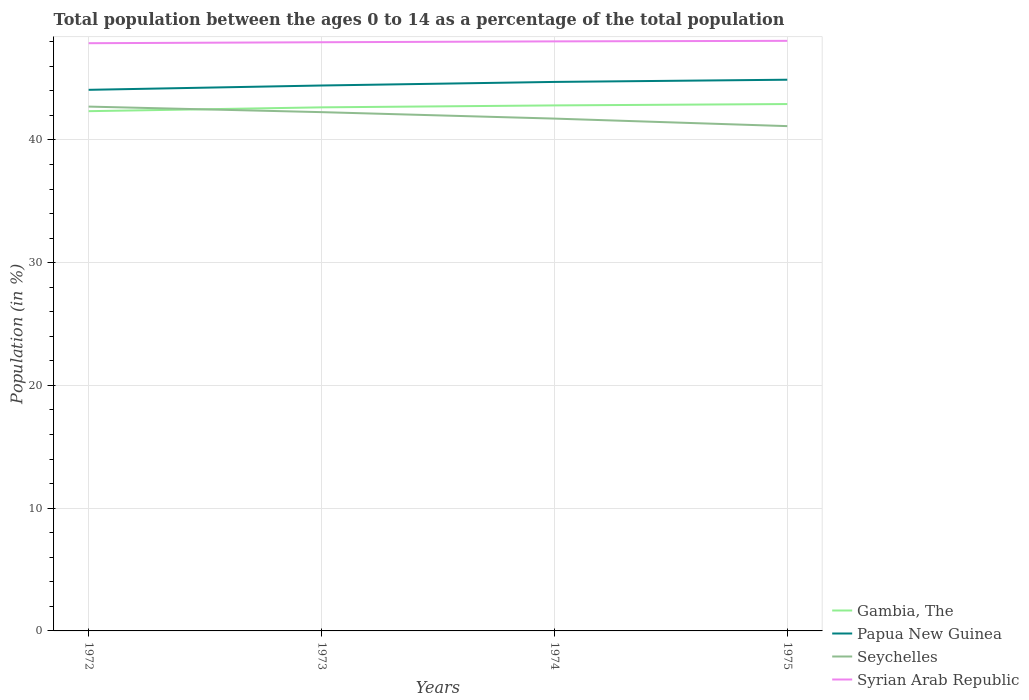Is the number of lines equal to the number of legend labels?
Your answer should be very brief. Yes. Across all years, what is the maximum percentage of the population ages 0 to 14 in Syrian Arab Republic?
Offer a terse response. 47.88. In which year was the percentage of the population ages 0 to 14 in Seychelles maximum?
Provide a succinct answer. 1975. What is the total percentage of the population ages 0 to 14 in Syrian Arab Republic in the graph?
Offer a very short reply. -0.08. What is the difference between the highest and the second highest percentage of the population ages 0 to 14 in Gambia, The?
Make the answer very short. 0.58. Is the percentage of the population ages 0 to 14 in Papua New Guinea strictly greater than the percentage of the population ages 0 to 14 in Seychelles over the years?
Offer a terse response. No. What is the difference between two consecutive major ticks on the Y-axis?
Your answer should be very brief. 10. Does the graph contain any zero values?
Provide a succinct answer. No. What is the title of the graph?
Your answer should be compact. Total population between the ages 0 to 14 as a percentage of the total population. What is the label or title of the X-axis?
Your answer should be compact. Years. What is the Population (in %) of Gambia, The in 1972?
Ensure brevity in your answer.  42.34. What is the Population (in %) of Papua New Guinea in 1972?
Keep it short and to the point. 44.08. What is the Population (in %) of Seychelles in 1972?
Your response must be concise. 42.72. What is the Population (in %) of Syrian Arab Republic in 1972?
Keep it short and to the point. 47.88. What is the Population (in %) in Gambia, The in 1973?
Offer a terse response. 42.66. What is the Population (in %) in Papua New Guinea in 1973?
Provide a short and direct response. 44.44. What is the Population (in %) of Seychelles in 1973?
Give a very brief answer. 42.27. What is the Population (in %) of Syrian Arab Republic in 1973?
Make the answer very short. 47.96. What is the Population (in %) of Gambia, The in 1974?
Offer a terse response. 42.82. What is the Population (in %) in Papua New Guinea in 1974?
Your response must be concise. 44.73. What is the Population (in %) of Seychelles in 1974?
Provide a succinct answer. 41.74. What is the Population (in %) of Syrian Arab Republic in 1974?
Ensure brevity in your answer.  48.03. What is the Population (in %) of Gambia, The in 1975?
Give a very brief answer. 42.93. What is the Population (in %) of Papua New Guinea in 1975?
Provide a short and direct response. 44.91. What is the Population (in %) of Seychelles in 1975?
Provide a short and direct response. 41.13. What is the Population (in %) of Syrian Arab Republic in 1975?
Your answer should be very brief. 48.08. Across all years, what is the maximum Population (in %) in Gambia, The?
Your answer should be very brief. 42.93. Across all years, what is the maximum Population (in %) of Papua New Guinea?
Your answer should be very brief. 44.91. Across all years, what is the maximum Population (in %) in Seychelles?
Make the answer very short. 42.72. Across all years, what is the maximum Population (in %) in Syrian Arab Republic?
Give a very brief answer. 48.08. Across all years, what is the minimum Population (in %) of Gambia, The?
Make the answer very short. 42.34. Across all years, what is the minimum Population (in %) of Papua New Guinea?
Keep it short and to the point. 44.08. Across all years, what is the minimum Population (in %) of Seychelles?
Offer a very short reply. 41.13. Across all years, what is the minimum Population (in %) in Syrian Arab Republic?
Keep it short and to the point. 47.88. What is the total Population (in %) of Gambia, The in the graph?
Your answer should be compact. 170.74. What is the total Population (in %) in Papua New Guinea in the graph?
Your answer should be very brief. 178.16. What is the total Population (in %) of Seychelles in the graph?
Make the answer very short. 167.85. What is the total Population (in %) of Syrian Arab Republic in the graph?
Offer a terse response. 191.95. What is the difference between the Population (in %) of Gambia, The in 1972 and that in 1973?
Your response must be concise. -0.31. What is the difference between the Population (in %) of Papua New Guinea in 1972 and that in 1973?
Provide a short and direct response. -0.35. What is the difference between the Population (in %) of Seychelles in 1972 and that in 1973?
Give a very brief answer. 0.45. What is the difference between the Population (in %) of Syrian Arab Republic in 1972 and that in 1973?
Your answer should be compact. -0.08. What is the difference between the Population (in %) of Gambia, The in 1972 and that in 1974?
Give a very brief answer. -0.47. What is the difference between the Population (in %) of Papua New Guinea in 1972 and that in 1974?
Your answer should be compact. -0.64. What is the difference between the Population (in %) in Seychelles in 1972 and that in 1974?
Your answer should be compact. 0.98. What is the difference between the Population (in %) in Syrian Arab Republic in 1972 and that in 1974?
Your answer should be very brief. -0.15. What is the difference between the Population (in %) of Gambia, The in 1972 and that in 1975?
Make the answer very short. -0.58. What is the difference between the Population (in %) in Papua New Guinea in 1972 and that in 1975?
Make the answer very short. -0.82. What is the difference between the Population (in %) of Seychelles in 1972 and that in 1975?
Provide a succinct answer. 1.59. What is the difference between the Population (in %) in Syrian Arab Republic in 1972 and that in 1975?
Ensure brevity in your answer.  -0.19. What is the difference between the Population (in %) in Gambia, The in 1973 and that in 1974?
Offer a very short reply. -0.16. What is the difference between the Population (in %) of Papua New Guinea in 1973 and that in 1974?
Ensure brevity in your answer.  -0.29. What is the difference between the Population (in %) of Seychelles in 1973 and that in 1974?
Provide a succinct answer. 0.53. What is the difference between the Population (in %) of Syrian Arab Republic in 1973 and that in 1974?
Provide a short and direct response. -0.07. What is the difference between the Population (in %) of Gambia, The in 1973 and that in 1975?
Give a very brief answer. -0.27. What is the difference between the Population (in %) in Papua New Guinea in 1973 and that in 1975?
Keep it short and to the point. -0.47. What is the difference between the Population (in %) of Seychelles in 1973 and that in 1975?
Your answer should be compact. 1.14. What is the difference between the Population (in %) in Syrian Arab Republic in 1973 and that in 1975?
Make the answer very short. -0.11. What is the difference between the Population (in %) in Gambia, The in 1974 and that in 1975?
Provide a succinct answer. -0.11. What is the difference between the Population (in %) in Papua New Guinea in 1974 and that in 1975?
Keep it short and to the point. -0.18. What is the difference between the Population (in %) in Seychelles in 1974 and that in 1975?
Give a very brief answer. 0.61. What is the difference between the Population (in %) of Syrian Arab Republic in 1974 and that in 1975?
Ensure brevity in your answer.  -0.04. What is the difference between the Population (in %) in Gambia, The in 1972 and the Population (in %) in Papua New Guinea in 1973?
Offer a terse response. -2.09. What is the difference between the Population (in %) in Gambia, The in 1972 and the Population (in %) in Seychelles in 1973?
Give a very brief answer. 0.08. What is the difference between the Population (in %) in Gambia, The in 1972 and the Population (in %) in Syrian Arab Republic in 1973?
Your answer should be compact. -5.62. What is the difference between the Population (in %) of Papua New Guinea in 1972 and the Population (in %) of Seychelles in 1973?
Keep it short and to the point. 1.82. What is the difference between the Population (in %) in Papua New Guinea in 1972 and the Population (in %) in Syrian Arab Republic in 1973?
Offer a terse response. -3.88. What is the difference between the Population (in %) in Seychelles in 1972 and the Population (in %) in Syrian Arab Republic in 1973?
Your answer should be very brief. -5.24. What is the difference between the Population (in %) in Gambia, The in 1972 and the Population (in %) in Papua New Guinea in 1974?
Provide a succinct answer. -2.38. What is the difference between the Population (in %) in Gambia, The in 1972 and the Population (in %) in Seychelles in 1974?
Your answer should be compact. 0.6. What is the difference between the Population (in %) in Gambia, The in 1972 and the Population (in %) in Syrian Arab Republic in 1974?
Offer a very short reply. -5.69. What is the difference between the Population (in %) of Papua New Guinea in 1972 and the Population (in %) of Seychelles in 1974?
Offer a very short reply. 2.34. What is the difference between the Population (in %) of Papua New Guinea in 1972 and the Population (in %) of Syrian Arab Republic in 1974?
Ensure brevity in your answer.  -3.95. What is the difference between the Population (in %) in Seychelles in 1972 and the Population (in %) in Syrian Arab Republic in 1974?
Offer a terse response. -5.31. What is the difference between the Population (in %) in Gambia, The in 1972 and the Population (in %) in Papua New Guinea in 1975?
Your answer should be very brief. -2.56. What is the difference between the Population (in %) in Gambia, The in 1972 and the Population (in %) in Seychelles in 1975?
Offer a terse response. 1.22. What is the difference between the Population (in %) of Gambia, The in 1972 and the Population (in %) of Syrian Arab Republic in 1975?
Provide a short and direct response. -5.73. What is the difference between the Population (in %) in Papua New Guinea in 1972 and the Population (in %) in Seychelles in 1975?
Offer a very short reply. 2.96. What is the difference between the Population (in %) of Papua New Guinea in 1972 and the Population (in %) of Syrian Arab Republic in 1975?
Your answer should be compact. -3.99. What is the difference between the Population (in %) of Seychelles in 1972 and the Population (in %) of Syrian Arab Republic in 1975?
Offer a very short reply. -5.36. What is the difference between the Population (in %) in Gambia, The in 1973 and the Population (in %) in Papua New Guinea in 1974?
Provide a short and direct response. -2.07. What is the difference between the Population (in %) in Gambia, The in 1973 and the Population (in %) in Seychelles in 1974?
Ensure brevity in your answer.  0.92. What is the difference between the Population (in %) of Gambia, The in 1973 and the Population (in %) of Syrian Arab Republic in 1974?
Your answer should be very brief. -5.37. What is the difference between the Population (in %) of Papua New Guinea in 1973 and the Population (in %) of Seychelles in 1974?
Offer a terse response. 2.7. What is the difference between the Population (in %) in Papua New Guinea in 1973 and the Population (in %) in Syrian Arab Republic in 1974?
Provide a succinct answer. -3.59. What is the difference between the Population (in %) of Seychelles in 1973 and the Population (in %) of Syrian Arab Republic in 1974?
Offer a very short reply. -5.76. What is the difference between the Population (in %) of Gambia, The in 1973 and the Population (in %) of Papua New Guinea in 1975?
Your response must be concise. -2.25. What is the difference between the Population (in %) in Gambia, The in 1973 and the Population (in %) in Seychelles in 1975?
Provide a succinct answer. 1.53. What is the difference between the Population (in %) in Gambia, The in 1973 and the Population (in %) in Syrian Arab Republic in 1975?
Provide a short and direct response. -5.42. What is the difference between the Population (in %) of Papua New Guinea in 1973 and the Population (in %) of Seychelles in 1975?
Give a very brief answer. 3.31. What is the difference between the Population (in %) of Papua New Guinea in 1973 and the Population (in %) of Syrian Arab Republic in 1975?
Your answer should be very brief. -3.64. What is the difference between the Population (in %) in Seychelles in 1973 and the Population (in %) in Syrian Arab Republic in 1975?
Provide a succinct answer. -5.81. What is the difference between the Population (in %) of Gambia, The in 1974 and the Population (in %) of Papua New Guinea in 1975?
Give a very brief answer. -2.09. What is the difference between the Population (in %) of Gambia, The in 1974 and the Population (in %) of Seychelles in 1975?
Make the answer very short. 1.69. What is the difference between the Population (in %) of Gambia, The in 1974 and the Population (in %) of Syrian Arab Republic in 1975?
Your answer should be compact. -5.26. What is the difference between the Population (in %) of Papua New Guinea in 1974 and the Population (in %) of Seychelles in 1975?
Offer a terse response. 3.6. What is the difference between the Population (in %) in Papua New Guinea in 1974 and the Population (in %) in Syrian Arab Republic in 1975?
Provide a short and direct response. -3.35. What is the difference between the Population (in %) in Seychelles in 1974 and the Population (in %) in Syrian Arab Republic in 1975?
Keep it short and to the point. -6.34. What is the average Population (in %) in Gambia, The per year?
Make the answer very short. 42.69. What is the average Population (in %) of Papua New Guinea per year?
Give a very brief answer. 44.54. What is the average Population (in %) in Seychelles per year?
Your answer should be very brief. 41.96. What is the average Population (in %) of Syrian Arab Republic per year?
Give a very brief answer. 47.99. In the year 1972, what is the difference between the Population (in %) in Gambia, The and Population (in %) in Papua New Guinea?
Your answer should be very brief. -1.74. In the year 1972, what is the difference between the Population (in %) of Gambia, The and Population (in %) of Seychelles?
Keep it short and to the point. -0.37. In the year 1972, what is the difference between the Population (in %) of Gambia, The and Population (in %) of Syrian Arab Republic?
Give a very brief answer. -5.54. In the year 1972, what is the difference between the Population (in %) of Papua New Guinea and Population (in %) of Seychelles?
Make the answer very short. 1.37. In the year 1972, what is the difference between the Population (in %) in Papua New Guinea and Population (in %) in Syrian Arab Republic?
Provide a short and direct response. -3.8. In the year 1972, what is the difference between the Population (in %) of Seychelles and Population (in %) of Syrian Arab Republic?
Your response must be concise. -5.16. In the year 1973, what is the difference between the Population (in %) of Gambia, The and Population (in %) of Papua New Guinea?
Your answer should be very brief. -1.78. In the year 1973, what is the difference between the Population (in %) in Gambia, The and Population (in %) in Seychelles?
Your answer should be very brief. 0.39. In the year 1973, what is the difference between the Population (in %) in Gambia, The and Population (in %) in Syrian Arab Republic?
Keep it short and to the point. -5.3. In the year 1973, what is the difference between the Population (in %) in Papua New Guinea and Population (in %) in Seychelles?
Make the answer very short. 2.17. In the year 1973, what is the difference between the Population (in %) in Papua New Guinea and Population (in %) in Syrian Arab Republic?
Make the answer very short. -3.52. In the year 1973, what is the difference between the Population (in %) of Seychelles and Population (in %) of Syrian Arab Republic?
Your answer should be very brief. -5.7. In the year 1974, what is the difference between the Population (in %) of Gambia, The and Population (in %) of Papua New Guinea?
Your answer should be very brief. -1.91. In the year 1974, what is the difference between the Population (in %) of Gambia, The and Population (in %) of Seychelles?
Offer a terse response. 1.08. In the year 1974, what is the difference between the Population (in %) of Gambia, The and Population (in %) of Syrian Arab Republic?
Give a very brief answer. -5.22. In the year 1974, what is the difference between the Population (in %) in Papua New Guinea and Population (in %) in Seychelles?
Ensure brevity in your answer.  2.99. In the year 1974, what is the difference between the Population (in %) of Papua New Guinea and Population (in %) of Syrian Arab Republic?
Make the answer very short. -3.3. In the year 1974, what is the difference between the Population (in %) in Seychelles and Population (in %) in Syrian Arab Republic?
Your answer should be very brief. -6.29. In the year 1975, what is the difference between the Population (in %) of Gambia, The and Population (in %) of Papua New Guinea?
Keep it short and to the point. -1.98. In the year 1975, what is the difference between the Population (in %) in Gambia, The and Population (in %) in Seychelles?
Provide a succinct answer. 1.8. In the year 1975, what is the difference between the Population (in %) of Gambia, The and Population (in %) of Syrian Arab Republic?
Your answer should be compact. -5.15. In the year 1975, what is the difference between the Population (in %) of Papua New Guinea and Population (in %) of Seychelles?
Your answer should be very brief. 3.78. In the year 1975, what is the difference between the Population (in %) in Papua New Guinea and Population (in %) in Syrian Arab Republic?
Give a very brief answer. -3.17. In the year 1975, what is the difference between the Population (in %) of Seychelles and Population (in %) of Syrian Arab Republic?
Your answer should be very brief. -6.95. What is the ratio of the Population (in %) of Papua New Guinea in 1972 to that in 1973?
Provide a short and direct response. 0.99. What is the ratio of the Population (in %) of Seychelles in 1972 to that in 1973?
Your response must be concise. 1.01. What is the ratio of the Population (in %) of Gambia, The in 1972 to that in 1974?
Keep it short and to the point. 0.99. What is the ratio of the Population (in %) of Papua New Guinea in 1972 to that in 1974?
Ensure brevity in your answer.  0.99. What is the ratio of the Population (in %) in Seychelles in 1972 to that in 1974?
Provide a short and direct response. 1.02. What is the ratio of the Population (in %) of Gambia, The in 1972 to that in 1975?
Make the answer very short. 0.99. What is the ratio of the Population (in %) of Papua New Guinea in 1972 to that in 1975?
Keep it short and to the point. 0.98. What is the ratio of the Population (in %) of Seychelles in 1972 to that in 1975?
Give a very brief answer. 1.04. What is the ratio of the Population (in %) in Papua New Guinea in 1973 to that in 1974?
Your answer should be compact. 0.99. What is the ratio of the Population (in %) of Seychelles in 1973 to that in 1974?
Give a very brief answer. 1.01. What is the ratio of the Population (in %) in Papua New Guinea in 1973 to that in 1975?
Keep it short and to the point. 0.99. What is the ratio of the Population (in %) of Seychelles in 1973 to that in 1975?
Provide a short and direct response. 1.03. What is the ratio of the Population (in %) of Syrian Arab Republic in 1973 to that in 1975?
Provide a succinct answer. 1. What is the ratio of the Population (in %) in Gambia, The in 1974 to that in 1975?
Offer a terse response. 1. What is the ratio of the Population (in %) in Seychelles in 1974 to that in 1975?
Provide a short and direct response. 1.01. What is the ratio of the Population (in %) of Syrian Arab Republic in 1974 to that in 1975?
Give a very brief answer. 1. What is the difference between the highest and the second highest Population (in %) of Gambia, The?
Make the answer very short. 0.11. What is the difference between the highest and the second highest Population (in %) in Papua New Guinea?
Your answer should be compact. 0.18. What is the difference between the highest and the second highest Population (in %) in Seychelles?
Provide a short and direct response. 0.45. What is the difference between the highest and the second highest Population (in %) of Syrian Arab Republic?
Your answer should be very brief. 0.04. What is the difference between the highest and the lowest Population (in %) in Gambia, The?
Offer a very short reply. 0.58. What is the difference between the highest and the lowest Population (in %) in Papua New Guinea?
Make the answer very short. 0.82. What is the difference between the highest and the lowest Population (in %) of Seychelles?
Ensure brevity in your answer.  1.59. What is the difference between the highest and the lowest Population (in %) in Syrian Arab Republic?
Your response must be concise. 0.19. 